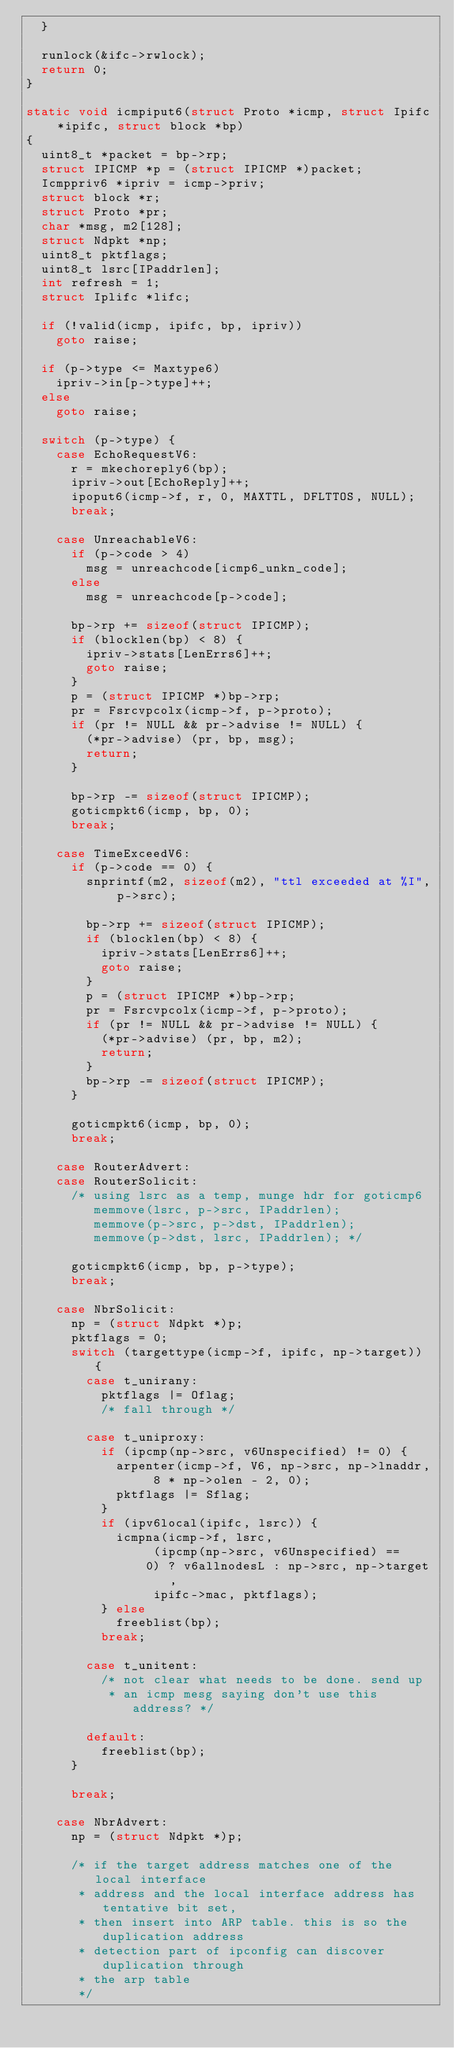Convert code to text. <code><loc_0><loc_0><loc_500><loc_500><_C_>	}

	runlock(&ifc->rwlock);
	return 0;
}

static void icmpiput6(struct Proto *icmp, struct Ipifc *ipifc, struct block *bp)
{
	uint8_t *packet = bp->rp;
	struct IPICMP *p = (struct IPICMP *)packet;
	Icmppriv6 *ipriv = icmp->priv;
	struct block *r;
	struct Proto *pr;
	char *msg, m2[128];
	struct Ndpkt *np;
	uint8_t pktflags;
	uint8_t lsrc[IPaddrlen];
	int refresh = 1;
	struct Iplifc *lifc;

	if (!valid(icmp, ipifc, bp, ipriv))
		goto raise;

	if (p->type <= Maxtype6)
		ipriv->in[p->type]++;
	else
		goto raise;

	switch (p->type) {
		case EchoRequestV6:
			r = mkechoreply6(bp);
			ipriv->out[EchoReply]++;
			ipoput6(icmp->f, r, 0, MAXTTL, DFLTTOS, NULL);
			break;

		case UnreachableV6:
			if (p->code > 4)
				msg = unreachcode[icmp6_unkn_code];
			else
				msg = unreachcode[p->code];

			bp->rp += sizeof(struct IPICMP);
			if (blocklen(bp) < 8) {
				ipriv->stats[LenErrs6]++;
				goto raise;
			}
			p = (struct IPICMP *)bp->rp;
			pr = Fsrcvpcolx(icmp->f, p->proto);
			if (pr != NULL && pr->advise != NULL) {
				(*pr->advise) (pr, bp, msg);
				return;
			}

			bp->rp -= sizeof(struct IPICMP);
			goticmpkt6(icmp, bp, 0);
			break;

		case TimeExceedV6:
			if (p->code == 0) {
				snprintf(m2, sizeof(m2), "ttl exceeded at %I", p->src);

				bp->rp += sizeof(struct IPICMP);
				if (blocklen(bp) < 8) {
					ipriv->stats[LenErrs6]++;
					goto raise;
				}
				p = (struct IPICMP *)bp->rp;
				pr = Fsrcvpcolx(icmp->f, p->proto);
				if (pr != NULL && pr->advise != NULL) {
					(*pr->advise) (pr, bp, m2);
					return;
				}
				bp->rp -= sizeof(struct IPICMP);
			}

			goticmpkt6(icmp, bp, 0);
			break;

		case RouterAdvert:
		case RouterSolicit:
			/* using lsrc as a temp, munge hdr for goticmp6 
			   memmove(lsrc, p->src, IPaddrlen);
			   memmove(p->src, p->dst, IPaddrlen);
			   memmove(p->dst, lsrc, IPaddrlen); */

			goticmpkt6(icmp, bp, p->type);
			break;

		case NbrSolicit:
			np = (struct Ndpkt *)p;
			pktflags = 0;
			switch (targettype(icmp->f, ipifc, np->target)) {
				case t_unirany:
					pktflags |= Oflag;
					/* fall through */

				case t_uniproxy:
					if (ipcmp(np->src, v6Unspecified) != 0) {
						arpenter(icmp->f, V6, np->src, np->lnaddr,
								 8 * np->olen - 2, 0);
						pktflags |= Sflag;
					}
					if (ipv6local(ipifc, lsrc)) {
						icmpna(icmp->f, lsrc,
							   (ipcmp(np->src, v6Unspecified) ==
								0) ? v6allnodesL : np->src, np->target,
							   ipifc->mac, pktflags);
					} else
						freeblist(bp);
					break;

				case t_unitent:
					/* not clear what needs to be done. send up
					 * an icmp mesg saying don't use this address? */

				default:
					freeblist(bp);
			}

			break;

		case NbrAdvert:
			np = (struct Ndpkt *)p;

			/* if the target address matches one of the local interface 
			 * address and the local interface address has tentative bit set, 
			 * then insert into ARP table. this is so the duplication address 
			 * detection part of ipconfig can discover duplication through 
			 * the arp table
			 */</code> 